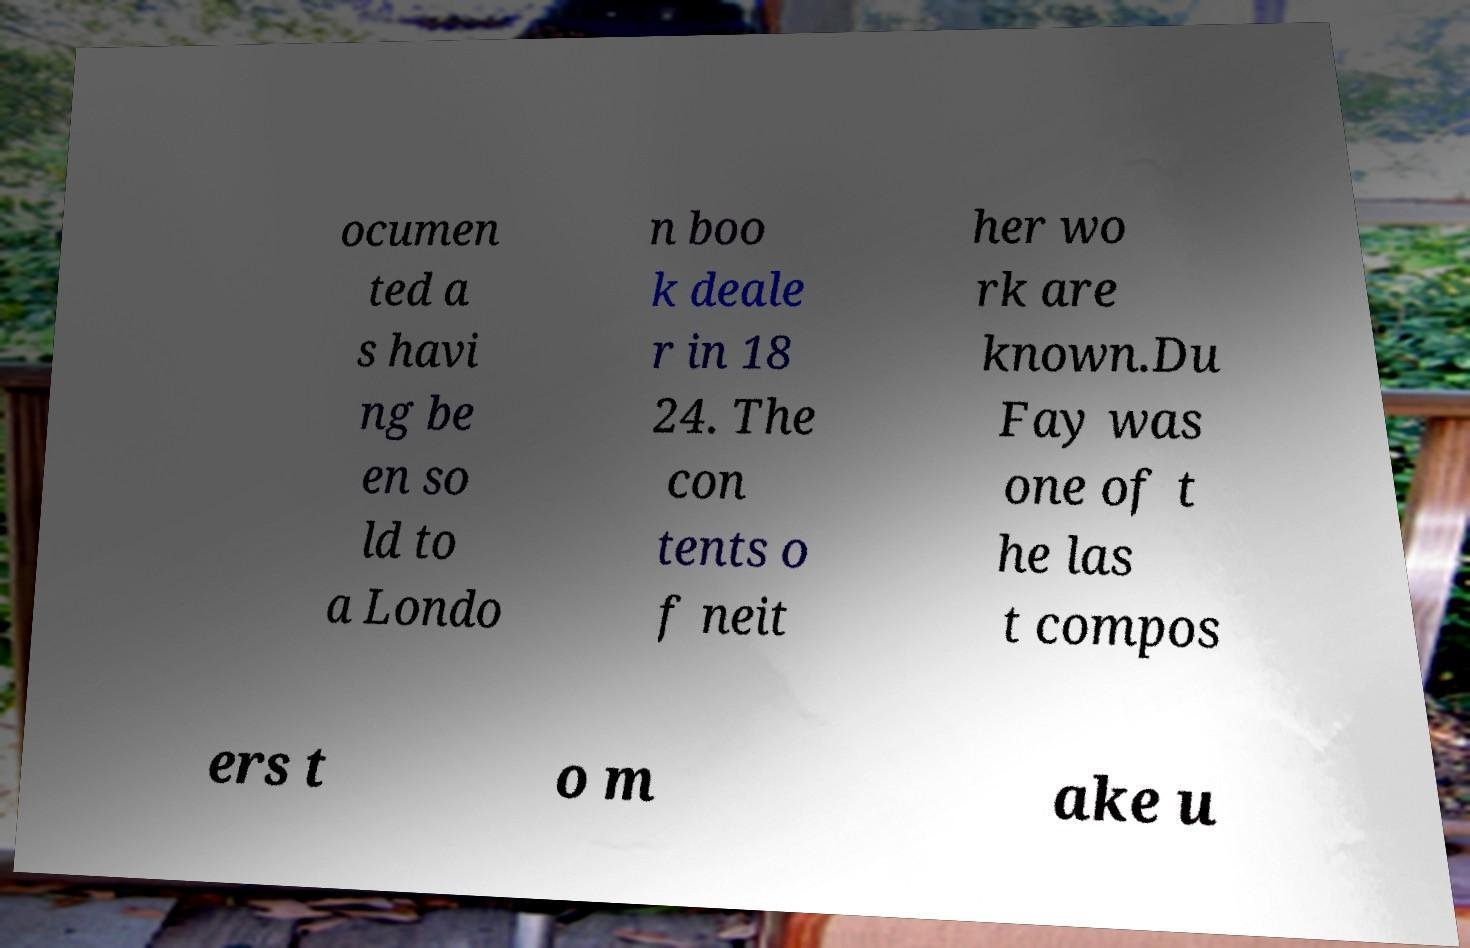Please identify and transcribe the text found in this image. ocumen ted a s havi ng be en so ld to a Londo n boo k deale r in 18 24. The con tents o f neit her wo rk are known.Du Fay was one of t he las t compos ers t o m ake u 